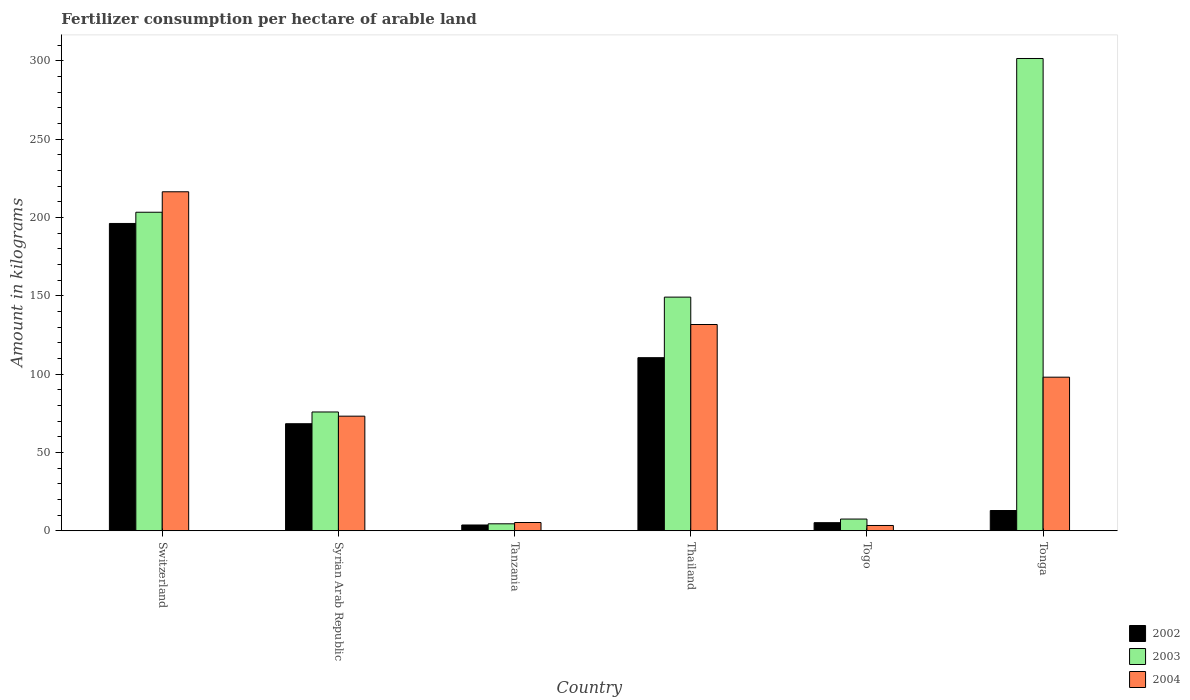Are the number of bars per tick equal to the number of legend labels?
Keep it short and to the point. Yes. What is the label of the 3rd group of bars from the left?
Keep it short and to the point. Tanzania. What is the amount of fertilizer consumption in 2004 in Syrian Arab Republic?
Offer a very short reply. 73.18. Across all countries, what is the maximum amount of fertilizer consumption in 2004?
Offer a very short reply. 216.44. Across all countries, what is the minimum amount of fertilizer consumption in 2002?
Keep it short and to the point. 3.7. In which country was the amount of fertilizer consumption in 2002 maximum?
Your response must be concise. Switzerland. In which country was the amount of fertilizer consumption in 2004 minimum?
Your answer should be very brief. Togo. What is the total amount of fertilizer consumption in 2003 in the graph?
Offer a very short reply. 741.88. What is the difference between the amount of fertilizer consumption in 2003 in Tanzania and that in Thailand?
Ensure brevity in your answer.  -144.72. What is the difference between the amount of fertilizer consumption in 2004 in Thailand and the amount of fertilizer consumption in 2003 in Tonga?
Your answer should be very brief. -169.84. What is the average amount of fertilizer consumption in 2003 per country?
Give a very brief answer. 123.65. What is the difference between the amount of fertilizer consumption of/in 2003 and amount of fertilizer consumption of/in 2004 in Thailand?
Keep it short and to the point. 17.49. In how many countries, is the amount of fertilizer consumption in 2003 greater than 260 kg?
Provide a short and direct response. 1. What is the ratio of the amount of fertilizer consumption in 2004 in Switzerland to that in Tonga?
Your answer should be compact. 2.21. Is the difference between the amount of fertilizer consumption in 2003 in Tanzania and Thailand greater than the difference between the amount of fertilizer consumption in 2004 in Tanzania and Thailand?
Provide a short and direct response. No. What is the difference between the highest and the second highest amount of fertilizer consumption in 2004?
Provide a short and direct response. 118.37. What is the difference between the highest and the lowest amount of fertilizer consumption in 2003?
Provide a short and direct response. 297.08. In how many countries, is the amount of fertilizer consumption in 2004 greater than the average amount of fertilizer consumption in 2004 taken over all countries?
Provide a short and direct response. 3. Is the sum of the amount of fertilizer consumption in 2003 in Thailand and Togo greater than the maximum amount of fertilizer consumption in 2004 across all countries?
Provide a succinct answer. No. Is it the case that in every country, the sum of the amount of fertilizer consumption in 2003 and amount of fertilizer consumption in 2002 is greater than the amount of fertilizer consumption in 2004?
Make the answer very short. Yes. How many bars are there?
Provide a succinct answer. 18. Are all the bars in the graph horizontal?
Your answer should be very brief. No. How many countries are there in the graph?
Provide a succinct answer. 6. What is the difference between two consecutive major ticks on the Y-axis?
Ensure brevity in your answer.  50. Does the graph contain any zero values?
Your answer should be compact. No. Does the graph contain grids?
Offer a very short reply. No. Where does the legend appear in the graph?
Offer a very short reply. Bottom right. What is the title of the graph?
Give a very brief answer. Fertilizer consumption per hectare of arable land. Does "1966" appear as one of the legend labels in the graph?
Your response must be concise. No. What is the label or title of the Y-axis?
Your answer should be compact. Amount in kilograms. What is the Amount in kilograms in 2002 in Switzerland?
Your answer should be very brief. 196.21. What is the Amount in kilograms in 2003 in Switzerland?
Offer a very short reply. 203.37. What is the Amount in kilograms in 2004 in Switzerland?
Provide a succinct answer. 216.44. What is the Amount in kilograms of 2002 in Syrian Arab Republic?
Offer a very short reply. 68.35. What is the Amount in kilograms of 2003 in Syrian Arab Republic?
Keep it short and to the point. 75.85. What is the Amount in kilograms in 2004 in Syrian Arab Republic?
Ensure brevity in your answer.  73.18. What is the Amount in kilograms in 2002 in Tanzania?
Your response must be concise. 3.7. What is the Amount in kilograms in 2003 in Tanzania?
Provide a succinct answer. 4.46. What is the Amount in kilograms in 2004 in Tanzania?
Your answer should be compact. 5.29. What is the Amount in kilograms in 2002 in Thailand?
Offer a very short reply. 110.52. What is the Amount in kilograms in 2003 in Thailand?
Keep it short and to the point. 149.18. What is the Amount in kilograms of 2004 in Thailand?
Your answer should be very brief. 131.7. What is the Amount in kilograms of 2002 in Togo?
Provide a short and direct response. 5.17. What is the Amount in kilograms in 2003 in Togo?
Offer a terse response. 7.49. What is the Amount in kilograms in 2004 in Togo?
Provide a short and direct response. 3.39. What is the Amount in kilograms in 2002 in Tonga?
Your response must be concise. 12.93. What is the Amount in kilograms of 2003 in Tonga?
Give a very brief answer. 301.53. What is the Amount in kilograms in 2004 in Tonga?
Your response must be concise. 98.07. Across all countries, what is the maximum Amount in kilograms of 2002?
Make the answer very short. 196.21. Across all countries, what is the maximum Amount in kilograms in 2003?
Offer a very short reply. 301.53. Across all countries, what is the maximum Amount in kilograms of 2004?
Your answer should be very brief. 216.44. Across all countries, what is the minimum Amount in kilograms in 2002?
Provide a short and direct response. 3.7. Across all countries, what is the minimum Amount in kilograms of 2003?
Provide a succinct answer. 4.46. Across all countries, what is the minimum Amount in kilograms of 2004?
Your answer should be compact. 3.39. What is the total Amount in kilograms of 2002 in the graph?
Ensure brevity in your answer.  396.89. What is the total Amount in kilograms of 2003 in the graph?
Keep it short and to the point. 741.88. What is the total Amount in kilograms of 2004 in the graph?
Your answer should be very brief. 528.06. What is the difference between the Amount in kilograms of 2002 in Switzerland and that in Syrian Arab Republic?
Ensure brevity in your answer.  127.85. What is the difference between the Amount in kilograms of 2003 in Switzerland and that in Syrian Arab Republic?
Offer a very short reply. 127.52. What is the difference between the Amount in kilograms in 2004 in Switzerland and that in Syrian Arab Republic?
Your response must be concise. 143.26. What is the difference between the Amount in kilograms of 2002 in Switzerland and that in Tanzania?
Provide a short and direct response. 192.51. What is the difference between the Amount in kilograms in 2003 in Switzerland and that in Tanzania?
Your answer should be very brief. 198.91. What is the difference between the Amount in kilograms in 2004 in Switzerland and that in Tanzania?
Your answer should be compact. 211.15. What is the difference between the Amount in kilograms of 2002 in Switzerland and that in Thailand?
Offer a terse response. 85.68. What is the difference between the Amount in kilograms in 2003 in Switzerland and that in Thailand?
Your answer should be compact. 54.19. What is the difference between the Amount in kilograms of 2004 in Switzerland and that in Thailand?
Your answer should be very brief. 84.74. What is the difference between the Amount in kilograms of 2002 in Switzerland and that in Togo?
Give a very brief answer. 191.03. What is the difference between the Amount in kilograms of 2003 in Switzerland and that in Togo?
Give a very brief answer. 195.88. What is the difference between the Amount in kilograms of 2004 in Switzerland and that in Togo?
Your answer should be compact. 213.04. What is the difference between the Amount in kilograms in 2002 in Switzerland and that in Tonga?
Give a very brief answer. 183.27. What is the difference between the Amount in kilograms of 2003 in Switzerland and that in Tonga?
Offer a very short reply. -98.16. What is the difference between the Amount in kilograms in 2004 in Switzerland and that in Tonga?
Keep it short and to the point. 118.37. What is the difference between the Amount in kilograms of 2002 in Syrian Arab Republic and that in Tanzania?
Give a very brief answer. 64.65. What is the difference between the Amount in kilograms of 2003 in Syrian Arab Republic and that in Tanzania?
Ensure brevity in your answer.  71.39. What is the difference between the Amount in kilograms of 2004 in Syrian Arab Republic and that in Tanzania?
Make the answer very short. 67.89. What is the difference between the Amount in kilograms of 2002 in Syrian Arab Republic and that in Thailand?
Offer a terse response. -42.17. What is the difference between the Amount in kilograms in 2003 in Syrian Arab Republic and that in Thailand?
Make the answer very short. -73.33. What is the difference between the Amount in kilograms in 2004 in Syrian Arab Republic and that in Thailand?
Provide a short and direct response. -58.51. What is the difference between the Amount in kilograms of 2002 in Syrian Arab Republic and that in Togo?
Your response must be concise. 63.18. What is the difference between the Amount in kilograms in 2003 in Syrian Arab Republic and that in Togo?
Your response must be concise. 68.36. What is the difference between the Amount in kilograms in 2004 in Syrian Arab Republic and that in Togo?
Your response must be concise. 69.79. What is the difference between the Amount in kilograms in 2002 in Syrian Arab Republic and that in Tonga?
Your answer should be compact. 55.42. What is the difference between the Amount in kilograms in 2003 in Syrian Arab Republic and that in Tonga?
Your response must be concise. -225.68. What is the difference between the Amount in kilograms in 2004 in Syrian Arab Republic and that in Tonga?
Offer a very short reply. -24.89. What is the difference between the Amount in kilograms in 2002 in Tanzania and that in Thailand?
Provide a succinct answer. -106.82. What is the difference between the Amount in kilograms of 2003 in Tanzania and that in Thailand?
Your answer should be very brief. -144.72. What is the difference between the Amount in kilograms of 2004 in Tanzania and that in Thailand?
Your answer should be compact. -126.41. What is the difference between the Amount in kilograms in 2002 in Tanzania and that in Togo?
Offer a terse response. -1.47. What is the difference between the Amount in kilograms of 2003 in Tanzania and that in Togo?
Your answer should be compact. -3.03. What is the difference between the Amount in kilograms in 2004 in Tanzania and that in Togo?
Provide a short and direct response. 1.9. What is the difference between the Amount in kilograms in 2002 in Tanzania and that in Tonga?
Offer a terse response. -9.23. What is the difference between the Amount in kilograms in 2003 in Tanzania and that in Tonga?
Your answer should be compact. -297.08. What is the difference between the Amount in kilograms of 2004 in Tanzania and that in Tonga?
Make the answer very short. -92.78. What is the difference between the Amount in kilograms of 2002 in Thailand and that in Togo?
Give a very brief answer. 105.35. What is the difference between the Amount in kilograms of 2003 in Thailand and that in Togo?
Give a very brief answer. 141.69. What is the difference between the Amount in kilograms in 2004 in Thailand and that in Togo?
Keep it short and to the point. 128.3. What is the difference between the Amount in kilograms in 2002 in Thailand and that in Tonga?
Give a very brief answer. 97.59. What is the difference between the Amount in kilograms of 2003 in Thailand and that in Tonga?
Make the answer very short. -152.35. What is the difference between the Amount in kilograms in 2004 in Thailand and that in Tonga?
Offer a very short reply. 33.63. What is the difference between the Amount in kilograms of 2002 in Togo and that in Tonga?
Offer a terse response. -7.76. What is the difference between the Amount in kilograms of 2003 in Togo and that in Tonga?
Offer a terse response. -294.04. What is the difference between the Amount in kilograms of 2004 in Togo and that in Tonga?
Provide a succinct answer. -94.67. What is the difference between the Amount in kilograms in 2002 in Switzerland and the Amount in kilograms in 2003 in Syrian Arab Republic?
Your answer should be very brief. 120.36. What is the difference between the Amount in kilograms of 2002 in Switzerland and the Amount in kilograms of 2004 in Syrian Arab Republic?
Provide a succinct answer. 123.03. What is the difference between the Amount in kilograms of 2003 in Switzerland and the Amount in kilograms of 2004 in Syrian Arab Republic?
Your answer should be very brief. 130.19. What is the difference between the Amount in kilograms in 2002 in Switzerland and the Amount in kilograms in 2003 in Tanzania?
Make the answer very short. 191.75. What is the difference between the Amount in kilograms in 2002 in Switzerland and the Amount in kilograms in 2004 in Tanzania?
Ensure brevity in your answer.  190.92. What is the difference between the Amount in kilograms of 2003 in Switzerland and the Amount in kilograms of 2004 in Tanzania?
Offer a terse response. 198.08. What is the difference between the Amount in kilograms in 2002 in Switzerland and the Amount in kilograms in 2003 in Thailand?
Offer a terse response. 47.03. What is the difference between the Amount in kilograms of 2002 in Switzerland and the Amount in kilograms of 2004 in Thailand?
Provide a succinct answer. 64.51. What is the difference between the Amount in kilograms in 2003 in Switzerland and the Amount in kilograms in 2004 in Thailand?
Provide a succinct answer. 71.67. What is the difference between the Amount in kilograms in 2002 in Switzerland and the Amount in kilograms in 2003 in Togo?
Your response must be concise. 188.72. What is the difference between the Amount in kilograms in 2002 in Switzerland and the Amount in kilograms in 2004 in Togo?
Make the answer very short. 192.81. What is the difference between the Amount in kilograms of 2003 in Switzerland and the Amount in kilograms of 2004 in Togo?
Keep it short and to the point. 199.98. What is the difference between the Amount in kilograms in 2002 in Switzerland and the Amount in kilograms in 2003 in Tonga?
Ensure brevity in your answer.  -105.33. What is the difference between the Amount in kilograms of 2002 in Switzerland and the Amount in kilograms of 2004 in Tonga?
Provide a short and direct response. 98.14. What is the difference between the Amount in kilograms in 2003 in Switzerland and the Amount in kilograms in 2004 in Tonga?
Your answer should be compact. 105.3. What is the difference between the Amount in kilograms in 2002 in Syrian Arab Republic and the Amount in kilograms in 2003 in Tanzania?
Your answer should be compact. 63.9. What is the difference between the Amount in kilograms of 2002 in Syrian Arab Republic and the Amount in kilograms of 2004 in Tanzania?
Make the answer very short. 63.06. What is the difference between the Amount in kilograms of 2003 in Syrian Arab Republic and the Amount in kilograms of 2004 in Tanzania?
Your response must be concise. 70.56. What is the difference between the Amount in kilograms in 2002 in Syrian Arab Republic and the Amount in kilograms in 2003 in Thailand?
Your answer should be very brief. -80.83. What is the difference between the Amount in kilograms of 2002 in Syrian Arab Republic and the Amount in kilograms of 2004 in Thailand?
Your answer should be very brief. -63.34. What is the difference between the Amount in kilograms of 2003 in Syrian Arab Republic and the Amount in kilograms of 2004 in Thailand?
Give a very brief answer. -55.85. What is the difference between the Amount in kilograms in 2002 in Syrian Arab Republic and the Amount in kilograms in 2003 in Togo?
Your answer should be compact. 60.86. What is the difference between the Amount in kilograms in 2002 in Syrian Arab Republic and the Amount in kilograms in 2004 in Togo?
Offer a very short reply. 64.96. What is the difference between the Amount in kilograms in 2003 in Syrian Arab Republic and the Amount in kilograms in 2004 in Togo?
Your response must be concise. 72.46. What is the difference between the Amount in kilograms in 2002 in Syrian Arab Republic and the Amount in kilograms in 2003 in Tonga?
Offer a very short reply. -233.18. What is the difference between the Amount in kilograms in 2002 in Syrian Arab Republic and the Amount in kilograms in 2004 in Tonga?
Keep it short and to the point. -29.71. What is the difference between the Amount in kilograms of 2003 in Syrian Arab Republic and the Amount in kilograms of 2004 in Tonga?
Ensure brevity in your answer.  -22.22. What is the difference between the Amount in kilograms in 2002 in Tanzania and the Amount in kilograms in 2003 in Thailand?
Ensure brevity in your answer.  -145.48. What is the difference between the Amount in kilograms of 2002 in Tanzania and the Amount in kilograms of 2004 in Thailand?
Make the answer very short. -128. What is the difference between the Amount in kilograms in 2003 in Tanzania and the Amount in kilograms in 2004 in Thailand?
Provide a short and direct response. -127.24. What is the difference between the Amount in kilograms of 2002 in Tanzania and the Amount in kilograms of 2003 in Togo?
Keep it short and to the point. -3.79. What is the difference between the Amount in kilograms of 2002 in Tanzania and the Amount in kilograms of 2004 in Togo?
Provide a short and direct response. 0.31. What is the difference between the Amount in kilograms of 2003 in Tanzania and the Amount in kilograms of 2004 in Togo?
Offer a terse response. 1.06. What is the difference between the Amount in kilograms in 2002 in Tanzania and the Amount in kilograms in 2003 in Tonga?
Your answer should be compact. -297.83. What is the difference between the Amount in kilograms of 2002 in Tanzania and the Amount in kilograms of 2004 in Tonga?
Make the answer very short. -94.37. What is the difference between the Amount in kilograms of 2003 in Tanzania and the Amount in kilograms of 2004 in Tonga?
Make the answer very short. -93.61. What is the difference between the Amount in kilograms in 2002 in Thailand and the Amount in kilograms in 2003 in Togo?
Your response must be concise. 103.03. What is the difference between the Amount in kilograms in 2002 in Thailand and the Amount in kilograms in 2004 in Togo?
Ensure brevity in your answer.  107.13. What is the difference between the Amount in kilograms in 2003 in Thailand and the Amount in kilograms in 2004 in Togo?
Your answer should be compact. 145.79. What is the difference between the Amount in kilograms of 2002 in Thailand and the Amount in kilograms of 2003 in Tonga?
Your answer should be compact. -191.01. What is the difference between the Amount in kilograms in 2002 in Thailand and the Amount in kilograms in 2004 in Tonga?
Your answer should be very brief. 12.46. What is the difference between the Amount in kilograms in 2003 in Thailand and the Amount in kilograms in 2004 in Tonga?
Your answer should be compact. 51.11. What is the difference between the Amount in kilograms in 2002 in Togo and the Amount in kilograms in 2003 in Tonga?
Your response must be concise. -296.36. What is the difference between the Amount in kilograms in 2002 in Togo and the Amount in kilograms in 2004 in Tonga?
Your answer should be compact. -92.89. What is the difference between the Amount in kilograms in 2003 in Togo and the Amount in kilograms in 2004 in Tonga?
Keep it short and to the point. -90.58. What is the average Amount in kilograms in 2002 per country?
Keep it short and to the point. 66.15. What is the average Amount in kilograms of 2003 per country?
Your answer should be compact. 123.65. What is the average Amount in kilograms of 2004 per country?
Your answer should be very brief. 88.01. What is the difference between the Amount in kilograms in 2002 and Amount in kilograms in 2003 in Switzerland?
Make the answer very short. -7.16. What is the difference between the Amount in kilograms of 2002 and Amount in kilograms of 2004 in Switzerland?
Provide a succinct answer. -20.23. What is the difference between the Amount in kilograms in 2003 and Amount in kilograms in 2004 in Switzerland?
Your answer should be compact. -13.07. What is the difference between the Amount in kilograms in 2002 and Amount in kilograms in 2003 in Syrian Arab Republic?
Provide a short and direct response. -7.5. What is the difference between the Amount in kilograms of 2002 and Amount in kilograms of 2004 in Syrian Arab Republic?
Offer a very short reply. -4.83. What is the difference between the Amount in kilograms of 2003 and Amount in kilograms of 2004 in Syrian Arab Republic?
Your answer should be compact. 2.67. What is the difference between the Amount in kilograms in 2002 and Amount in kilograms in 2003 in Tanzania?
Make the answer very short. -0.76. What is the difference between the Amount in kilograms in 2002 and Amount in kilograms in 2004 in Tanzania?
Provide a short and direct response. -1.59. What is the difference between the Amount in kilograms in 2003 and Amount in kilograms in 2004 in Tanzania?
Your response must be concise. -0.83. What is the difference between the Amount in kilograms of 2002 and Amount in kilograms of 2003 in Thailand?
Make the answer very short. -38.66. What is the difference between the Amount in kilograms in 2002 and Amount in kilograms in 2004 in Thailand?
Keep it short and to the point. -21.17. What is the difference between the Amount in kilograms of 2003 and Amount in kilograms of 2004 in Thailand?
Keep it short and to the point. 17.49. What is the difference between the Amount in kilograms in 2002 and Amount in kilograms in 2003 in Togo?
Offer a very short reply. -2.32. What is the difference between the Amount in kilograms of 2002 and Amount in kilograms of 2004 in Togo?
Ensure brevity in your answer.  1.78. What is the difference between the Amount in kilograms of 2003 and Amount in kilograms of 2004 in Togo?
Your answer should be compact. 4.1. What is the difference between the Amount in kilograms in 2002 and Amount in kilograms in 2003 in Tonga?
Offer a very short reply. -288.6. What is the difference between the Amount in kilograms in 2002 and Amount in kilograms in 2004 in Tonga?
Give a very brief answer. -85.13. What is the difference between the Amount in kilograms of 2003 and Amount in kilograms of 2004 in Tonga?
Offer a very short reply. 203.47. What is the ratio of the Amount in kilograms in 2002 in Switzerland to that in Syrian Arab Republic?
Your answer should be very brief. 2.87. What is the ratio of the Amount in kilograms in 2003 in Switzerland to that in Syrian Arab Republic?
Provide a succinct answer. 2.68. What is the ratio of the Amount in kilograms in 2004 in Switzerland to that in Syrian Arab Republic?
Give a very brief answer. 2.96. What is the ratio of the Amount in kilograms in 2002 in Switzerland to that in Tanzania?
Provide a succinct answer. 53.03. What is the ratio of the Amount in kilograms of 2003 in Switzerland to that in Tanzania?
Provide a short and direct response. 45.64. What is the ratio of the Amount in kilograms in 2004 in Switzerland to that in Tanzania?
Make the answer very short. 40.92. What is the ratio of the Amount in kilograms of 2002 in Switzerland to that in Thailand?
Your answer should be compact. 1.78. What is the ratio of the Amount in kilograms in 2003 in Switzerland to that in Thailand?
Ensure brevity in your answer.  1.36. What is the ratio of the Amount in kilograms of 2004 in Switzerland to that in Thailand?
Provide a short and direct response. 1.64. What is the ratio of the Amount in kilograms of 2002 in Switzerland to that in Togo?
Provide a succinct answer. 37.93. What is the ratio of the Amount in kilograms in 2003 in Switzerland to that in Togo?
Make the answer very short. 27.16. What is the ratio of the Amount in kilograms in 2004 in Switzerland to that in Togo?
Make the answer very short. 63.79. What is the ratio of the Amount in kilograms of 2002 in Switzerland to that in Tonga?
Make the answer very short. 15.17. What is the ratio of the Amount in kilograms of 2003 in Switzerland to that in Tonga?
Provide a short and direct response. 0.67. What is the ratio of the Amount in kilograms in 2004 in Switzerland to that in Tonga?
Offer a terse response. 2.21. What is the ratio of the Amount in kilograms in 2002 in Syrian Arab Republic to that in Tanzania?
Provide a succinct answer. 18.47. What is the ratio of the Amount in kilograms in 2003 in Syrian Arab Republic to that in Tanzania?
Provide a succinct answer. 17.02. What is the ratio of the Amount in kilograms in 2004 in Syrian Arab Republic to that in Tanzania?
Offer a very short reply. 13.84. What is the ratio of the Amount in kilograms in 2002 in Syrian Arab Republic to that in Thailand?
Ensure brevity in your answer.  0.62. What is the ratio of the Amount in kilograms of 2003 in Syrian Arab Republic to that in Thailand?
Offer a terse response. 0.51. What is the ratio of the Amount in kilograms in 2004 in Syrian Arab Republic to that in Thailand?
Offer a very short reply. 0.56. What is the ratio of the Amount in kilograms of 2002 in Syrian Arab Republic to that in Togo?
Keep it short and to the point. 13.21. What is the ratio of the Amount in kilograms of 2003 in Syrian Arab Republic to that in Togo?
Give a very brief answer. 10.13. What is the ratio of the Amount in kilograms of 2004 in Syrian Arab Republic to that in Togo?
Your answer should be very brief. 21.57. What is the ratio of the Amount in kilograms in 2002 in Syrian Arab Republic to that in Tonga?
Your response must be concise. 5.29. What is the ratio of the Amount in kilograms in 2003 in Syrian Arab Republic to that in Tonga?
Your answer should be compact. 0.25. What is the ratio of the Amount in kilograms in 2004 in Syrian Arab Republic to that in Tonga?
Ensure brevity in your answer.  0.75. What is the ratio of the Amount in kilograms in 2002 in Tanzania to that in Thailand?
Provide a short and direct response. 0.03. What is the ratio of the Amount in kilograms in 2003 in Tanzania to that in Thailand?
Your answer should be compact. 0.03. What is the ratio of the Amount in kilograms in 2004 in Tanzania to that in Thailand?
Give a very brief answer. 0.04. What is the ratio of the Amount in kilograms of 2002 in Tanzania to that in Togo?
Your answer should be compact. 0.72. What is the ratio of the Amount in kilograms of 2003 in Tanzania to that in Togo?
Your answer should be compact. 0.59. What is the ratio of the Amount in kilograms in 2004 in Tanzania to that in Togo?
Offer a terse response. 1.56. What is the ratio of the Amount in kilograms of 2002 in Tanzania to that in Tonga?
Offer a terse response. 0.29. What is the ratio of the Amount in kilograms in 2003 in Tanzania to that in Tonga?
Offer a terse response. 0.01. What is the ratio of the Amount in kilograms in 2004 in Tanzania to that in Tonga?
Give a very brief answer. 0.05. What is the ratio of the Amount in kilograms of 2002 in Thailand to that in Togo?
Offer a very short reply. 21.37. What is the ratio of the Amount in kilograms in 2003 in Thailand to that in Togo?
Offer a very short reply. 19.92. What is the ratio of the Amount in kilograms in 2004 in Thailand to that in Togo?
Keep it short and to the point. 38.81. What is the ratio of the Amount in kilograms of 2002 in Thailand to that in Tonga?
Give a very brief answer. 8.55. What is the ratio of the Amount in kilograms in 2003 in Thailand to that in Tonga?
Your response must be concise. 0.49. What is the ratio of the Amount in kilograms of 2004 in Thailand to that in Tonga?
Provide a succinct answer. 1.34. What is the ratio of the Amount in kilograms in 2002 in Togo to that in Tonga?
Provide a succinct answer. 0.4. What is the ratio of the Amount in kilograms in 2003 in Togo to that in Tonga?
Offer a very short reply. 0.02. What is the ratio of the Amount in kilograms in 2004 in Togo to that in Tonga?
Offer a terse response. 0.03. What is the difference between the highest and the second highest Amount in kilograms in 2002?
Provide a short and direct response. 85.68. What is the difference between the highest and the second highest Amount in kilograms in 2003?
Keep it short and to the point. 98.16. What is the difference between the highest and the second highest Amount in kilograms of 2004?
Provide a short and direct response. 84.74. What is the difference between the highest and the lowest Amount in kilograms of 2002?
Provide a short and direct response. 192.51. What is the difference between the highest and the lowest Amount in kilograms in 2003?
Ensure brevity in your answer.  297.08. What is the difference between the highest and the lowest Amount in kilograms of 2004?
Provide a short and direct response. 213.04. 